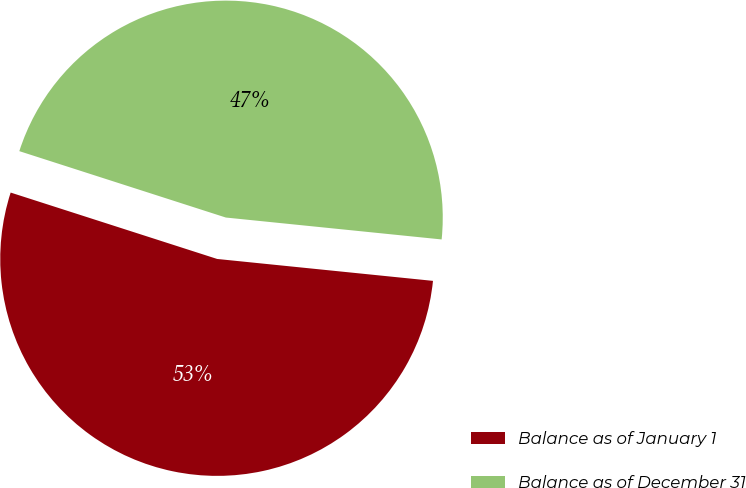Convert chart to OTSL. <chart><loc_0><loc_0><loc_500><loc_500><pie_chart><fcel>Balance as of January 1<fcel>Balance as of December 31<nl><fcel>53.34%<fcel>46.66%<nl></chart> 